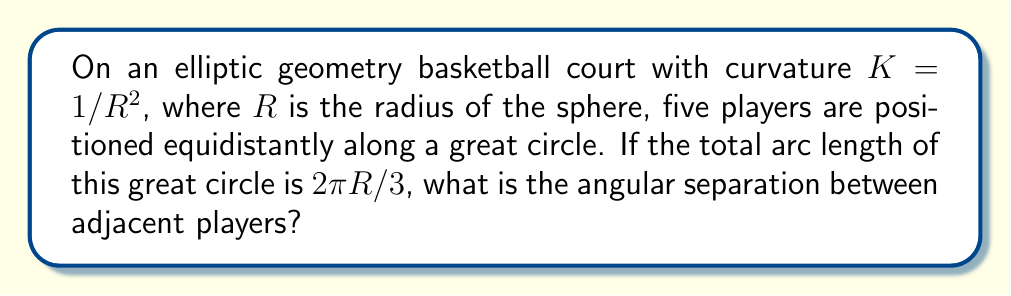Teach me how to tackle this problem. Let's approach this step-by-step:

1) In elliptic geometry, the court is on the surface of a sphere with radius $R$.

2) The players are positioned along a great circle, which is the intersection of the sphere with a plane passing through its center.

3) We're told that the total arc length of this great circle is $2\pi R/3$. This means it's $1/3$ of the full circumference of a great circle $(2\pi R)$.

4) The formula for arc length in spherical geometry is:

   $$s = R\theta$$

   where $s$ is the arc length, $R$ is the radius, and $\theta$ is the central angle in radians.

5) We can set up the equation:

   $$2\pi R/3 = R\theta$$

6) Simplifying:

   $$2\pi/3 = \theta$$

   This is the total central angle for all five players.

7) To find the angular separation between adjacent players, we need to divide this angle by the number of gaps between players (4):

   $$\theta_{separation} = \frac{2\pi/3}{4} = \frac{\pi}{6}$$

8) Converting to degrees:

   $$\frac{\pi}{6} \cdot \frac{180^{\circ}}{\pi} = 30^{\circ}$$

Therefore, the angular separation between adjacent players is $\pi/6$ radians or $30^{\circ}$.
Answer: $\pi/6$ radians or $30^{\circ}$ 